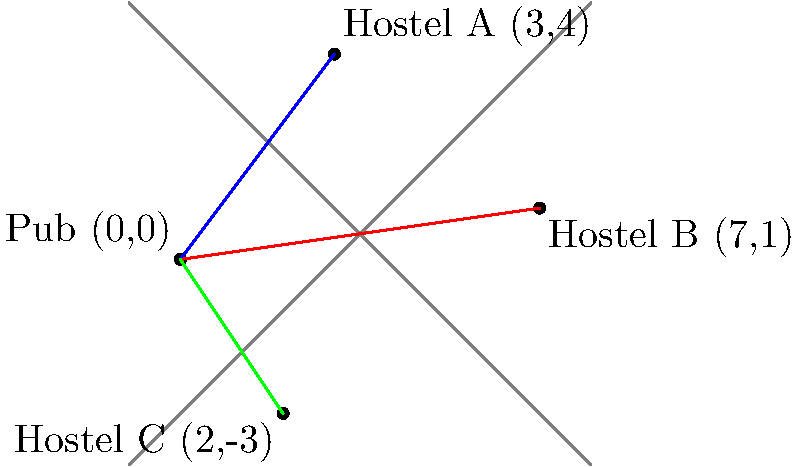Your pub is located at the origin (0,0) on a coordinate grid, where each unit represents 1 km. Three hostels are situated at different locations: Hostel A (3,4), Hostel B (7,1), and Hostel C (2,-3). Which hostel is the furthest from your pub, and what is the distance to it (rounded to one decimal place)? To solve this problem, we need to calculate the distance between the pub (0,0) and each hostel using the distance formula:

Distance = $\sqrt{(x_2-x_1)^2 + (y_2-y_1)^2}$

1. Distance to Hostel A (3,4):
   $d_A = \sqrt{(3-0)^2 + (4-0)^2} = \sqrt{9 + 16} = \sqrt{25} = 5$ km

2. Distance to Hostel B (7,1):
   $d_B = \sqrt{(7-0)^2 + (1-0)^2} = \sqrt{49 + 1} = \sqrt{50} \approx 7.1$ km

3. Distance to Hostel C (2,-3):
   $d_C = \sqrt{(2-0)^2 + (-3-0)^2} = \sqrt{4 + 9} = \sqrt{13} \approx 3.6$ km

Comparing the distances:
$d_A = 5$ km
$d_B \approx 7.1$ km
$d_C \approx 3.6$ km

The furthest hostel is Hostel B, with a distance of approximately 7.1 km from the pub.
Answer: Hostel B, 7.1 km 